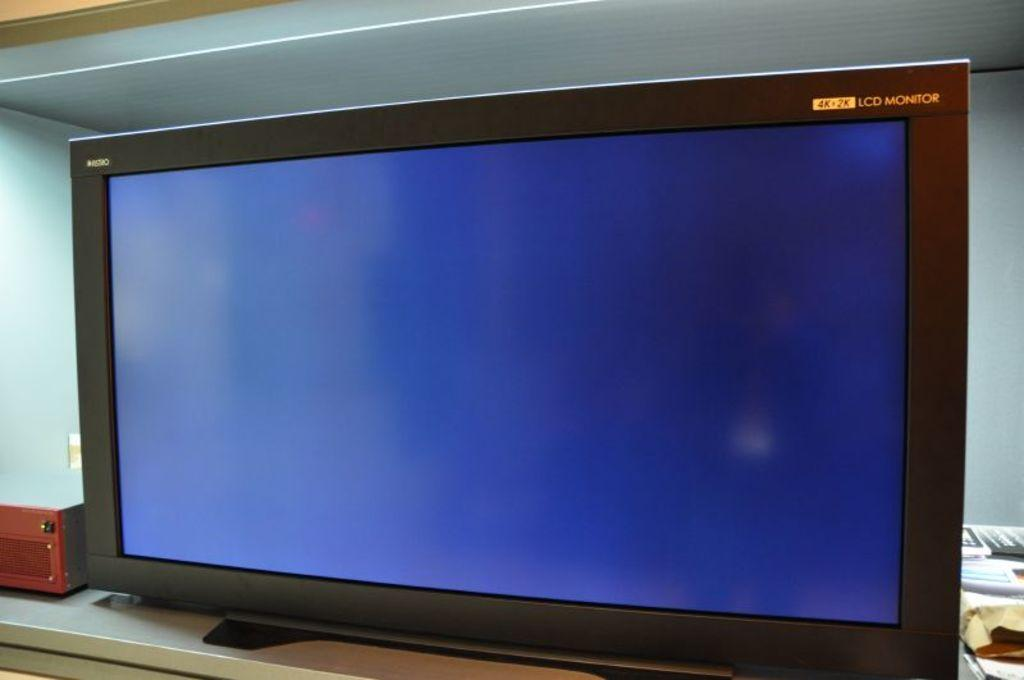<image>
Write a terse but informative summary of the picture. The television set is designed with LCD lighting. 